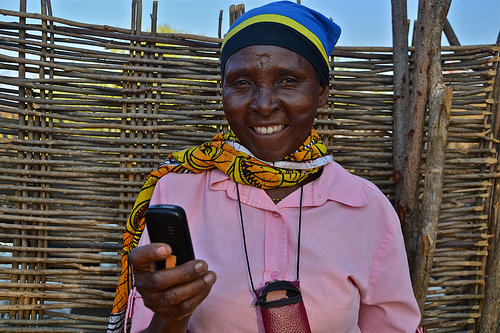<image>
Is there a phone in the black gold? No. The phone is not contained within the black gold. These objects have a different spatial relationship. 